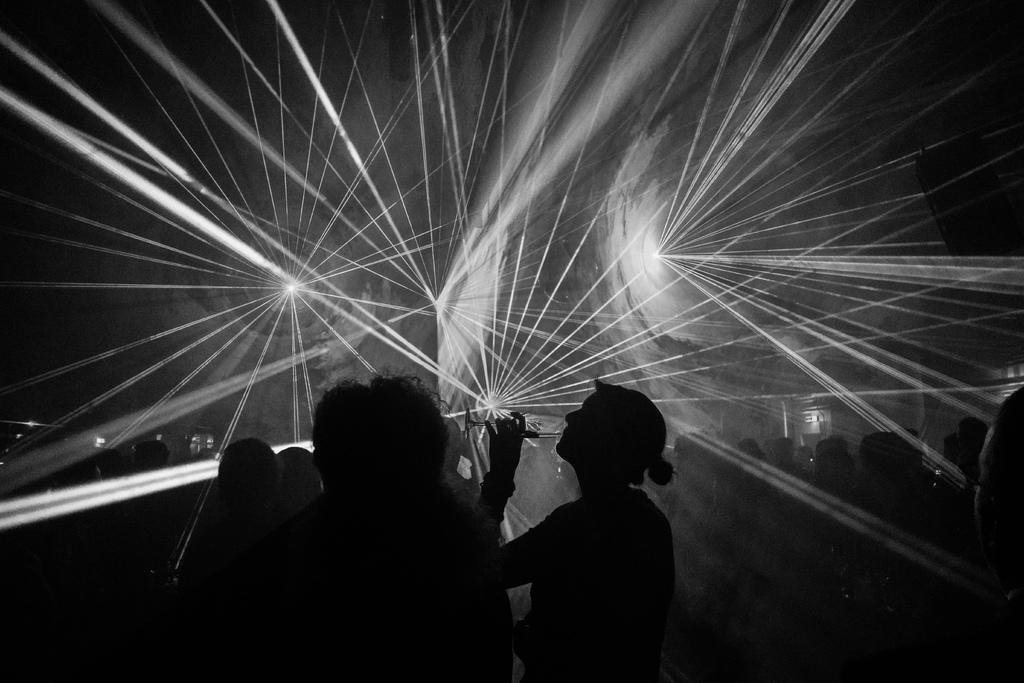What is the color scheme of the image? The image is black and white. What can be seen in the middle of the image? There are persons and lights in the middle of the image. What type of sweater is the person wearing in the image? There is no information about a sweater or clothing in the image, as it is black and white and only shows persons and lights. How often do the persons in the image wash their hands? There is no information about hand washing or any actions being performed by the persons in the image. 